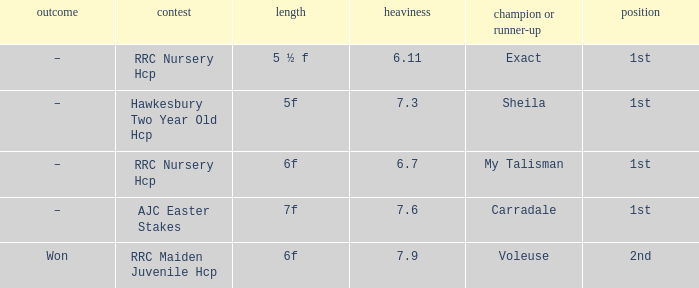What is the weight number when the distance was 5 ½ f? 1.0. 